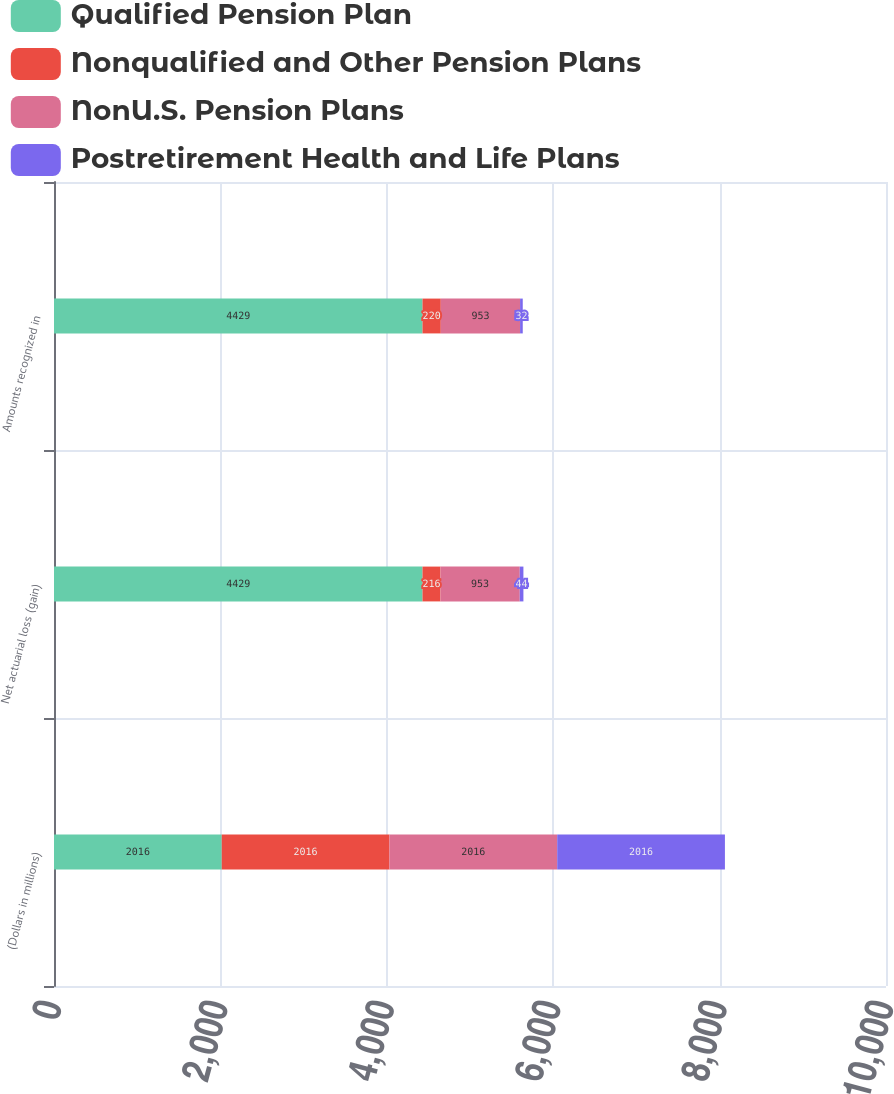<chart> <loc_0><loc_0><loc_500><loc_500><stacked_bar_chart><ecel><fcel>(Dollars in millions)<fcel>Net actuarial loss (gain)<fcel>Amounts recognized in<nl><fcel>Qualified Pension Plan<fcel>2016<fcel>4429<fcel>4429<nl><fcel>Nonqualified and Other Pension Plans<fcel>2016<fcel>216<fcel>220<nl><fcel>NonU.S. Pension Plans<fcel>2016<fcel>953<fcel>953<nl><fcel>Postretirement Health and Life Plans<fcel>2016<fcel>44<fcel>32<nl></chart> 